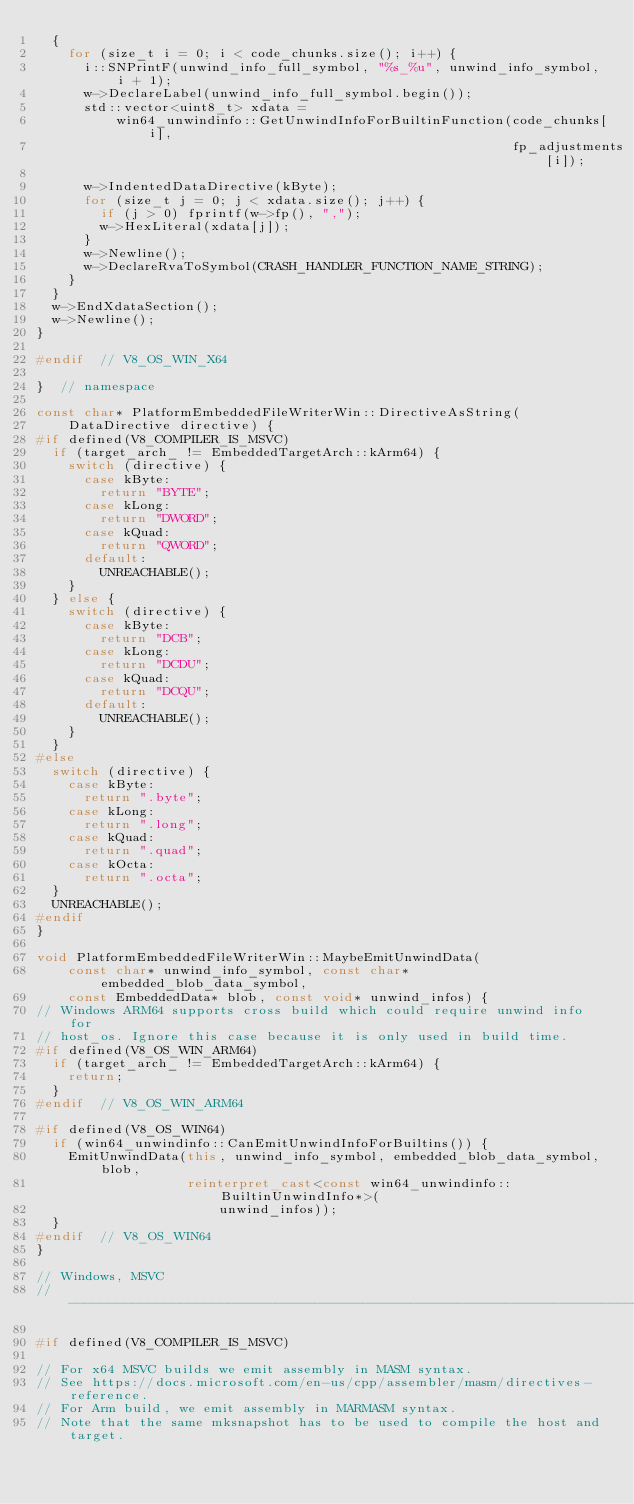<code> <loc_0><loc_0><loc_500><loc_500><_C++_>  {
    for (size_t i = 0; i < code_chunks.size(); i++) {
      i::SNPrintF(unwind_info_full_symbol, "%s_%u", unwind_info_symbol, i + 1);
      w->DeclareLabel(unwind_info_full_symbol.begin());
      std::vector<uint8_t> xdata =
          win64_unwindinfo::GetUnwindInfoForBuiltinFunction(code_chunks[i],
                                                            fp_adjustments[i]);

      w->IndentedDataDirective(kByte);
      for (size_t j = 0; j < xdata.size(); j++) {
        if (j > 0) fprintf(w->fp(), ",");
        w->HexLiteral(xdata[j]);
      }
      w->Newline();
      w->DeclareRvaToSymbol(CRASH_HANDLER_FUNCTION_NAME_STRING);
    }
  }
  w->EndXdataSection();
  w->Newline();
}

#endif  // V8_OS_WIN_X64

}  // namespace

const char* PlatformEmbeddedFileWriterWin::DirectiveAsString(
    DataDirective directive) {
#if defined(V8_COMPILER_IS_MSVC)
  if (target_arch_ != EmbeddedTargetArch::kArm64) {
    switch (directive) {
      case kByte:
        return "BYTE";
      case kLong:
        return "DWORD";
      case kQuad:
        return "QWORD";
      default:
        UNREACHABLE();
    }
  } else {
    switch (directive) {
      case kByte:
        return "DCB";
      case kLong:
        return "DCDU";
      case kQuad:
        return "DCQU";
      default:
        UNREACHABLE();
    }
  }
#else
  switch (directive) {
    case kByte:
      return ".byte";
    case kLong:
      return ".long";
    case kQuad:
      return ".quad";
    case kOcta:
      return ".octa";
  }
  UNREACHABLE();
#endif
}

void PlatformEmbeddedFileWriterWin::MaybeEmitUnwindData(
    const char* unwind_info_symbol, const char* embedded_blob_data_symbol,
    const EmbeddedData* blob, const void* unwind_infos) {
// Windows ARM64 supports cross build which could require unwind info for
// host_os. Ignore this case because it is only used in build time.
#if defined(V8_OS_WIN_ARM64)
  if (target_arch_ != EmbeddedTargetArch::kArm64) {
    return;
  }
#endif  // V8_OS_WIN_ARM64

#if defined(V8_OS_WIN64)
  if (win64_unwindinfo::CanEmitUnwindInfoForBuiltins()) {
    EmitUnwindData(this, unwind_info_symbol, embedded_blob_data_symbol, blob,
                   reinterpret_cast<const win64_unwindinfo::BuiltinUnwindInfo*>(
                       unwind_infos));
  }
#endif  // V8_OS_WIN64
}

// Windows, MSVC
// -----------------------------------------------------------------------------

#if defined(V8_COMPILER_IS_MSVC)

// For x64 MSVC builds we emit assembly in MASM syntax.
// See https://docs.microsoft.com/en-us/cpp/assembler/masm/directives-reference.
// For Arm build, we emit assembly in MARMASM syntax.
// Note that the same mksnapshot has to be used to compile the host and target.
</code> 